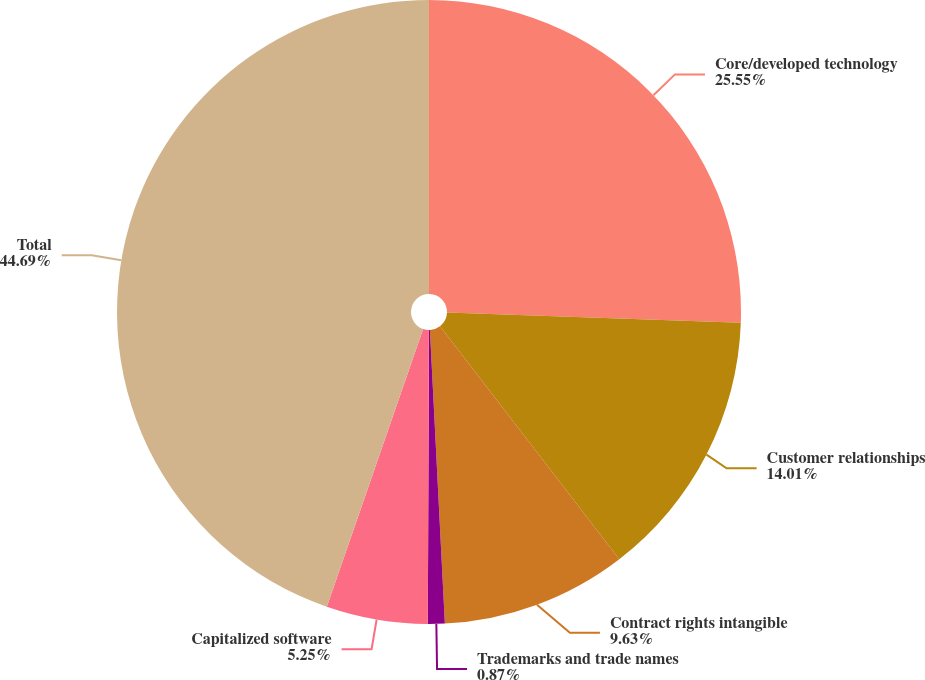Convert chart to OTSL. <chart><loc_0><loc_0><loc_500><loc_500><pie_chart><fcel>Core/developed technology<fcel>Customer relationships<fcel>Contract rights intangible<fcel>Trademarks and trade names<fcel>Capitalized software<fcel>Total<nl><fcel>25.55%<fcel>14.01%<fcel>9.63%<fcel>0.87%<fcel>5.25%<fcel>44.69%<nl></chart> 